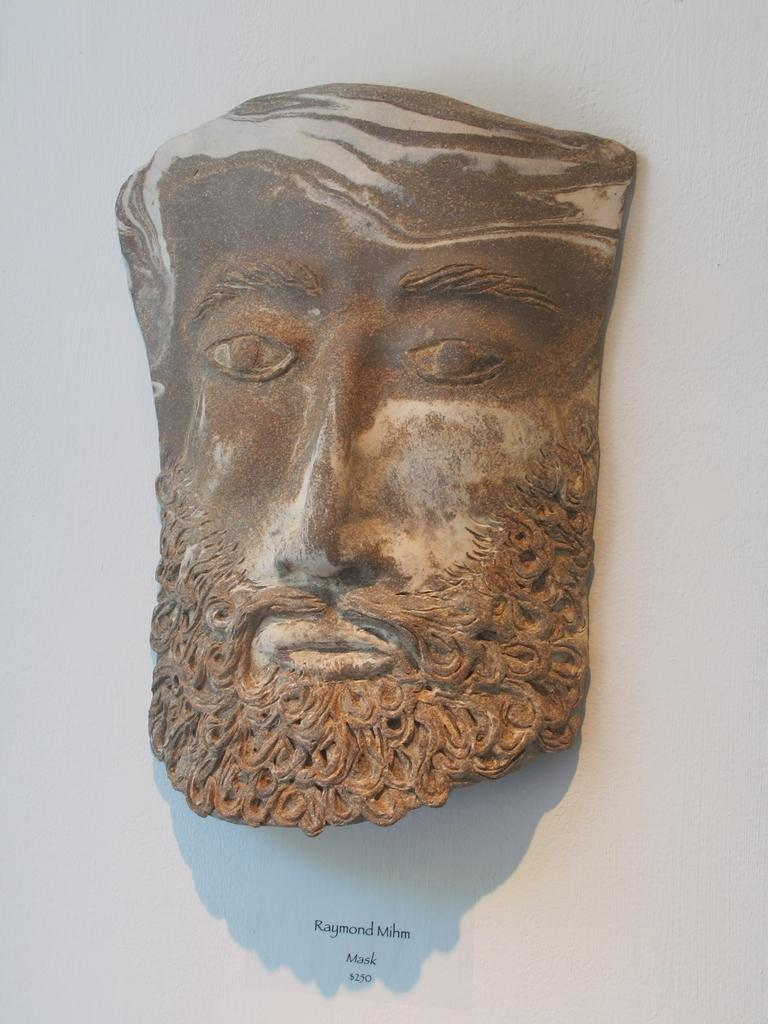What is the main subject of the image? There is a carved rock in the shape of a human face in the image. What can be seen in the background of the image? The background of the image is white. Absurd Question/Answer: What is the history of the fear that the carved rock face might be experiencing in the image? There is no indication of fear or any emotions in the image, as it only features a carved rock in the shape of a human face. The background is white, but there is no information about the history or context of the carving. Absurd Question/Answer: Is the carved rock face sinking into quicksand in the image? No, there is no quicksand present in the image. The carved rock face is on a solid surface, and the background is white. 